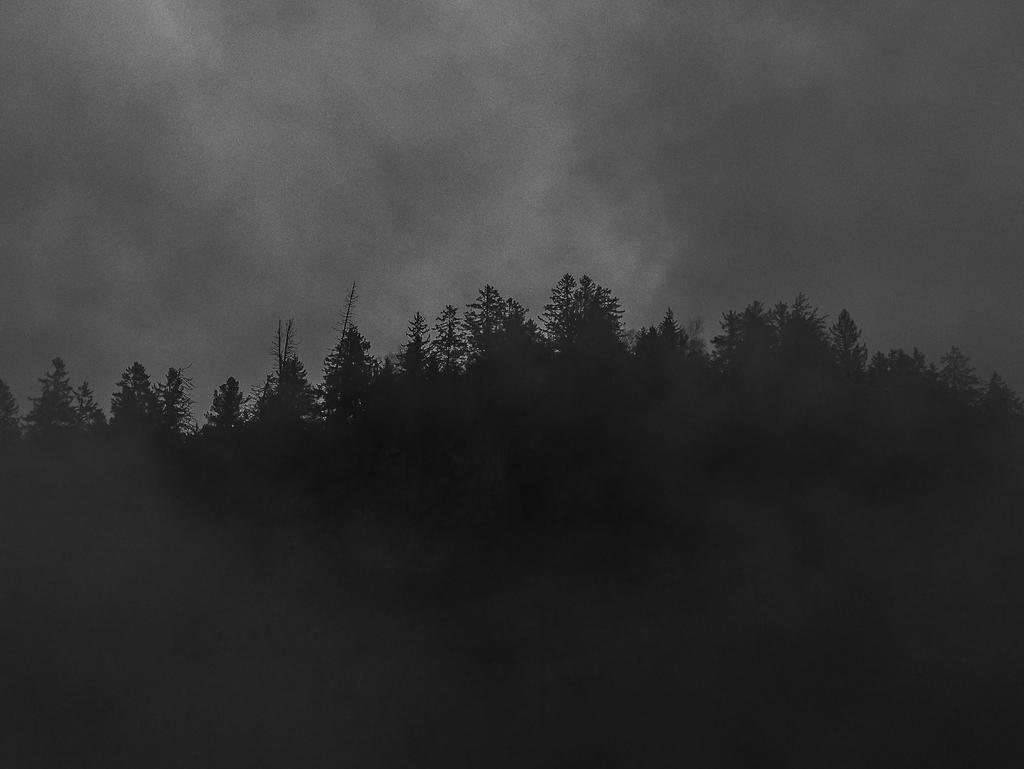What type of vegetation can be seen in the image? There are trees in the image. What part of the natural environment is visible in the image? The sky is visible in the image. What holiday is being celebrated in the image? There is no indication of a holiday being celebrated in the image. What is the taste of the trees in the image? Trees do not have a taste, as they are plants and not food items. 